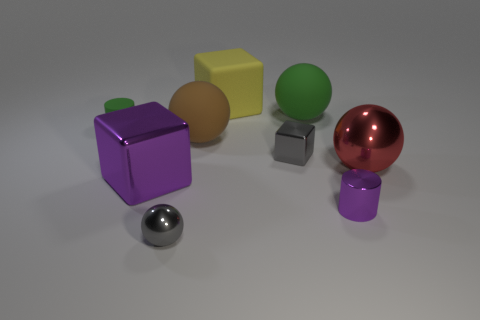What number of other things are there of the same material as the big yellow cube
Your answer should be compact. 3. Does the red ball have the same material as the tiny cylinder behind the red sphere?
Make the answer very short. No. Is the number of gray metallic objects that are to the right of the small purple object less than the number of purple shiny objects that are on the right side of the brown matte object?
Offer a very short reply. Yes. There is a cylinder that is right of the small gray cube; what color is it?
Make the answer very short. Purple. How many other things are there of the same color as the large metallic sphere?
Ensure brevity in your answer.  0. There is a gray shiny thing to the right of the yellow matte cube; is its size the same as the purple cylinder?
Provide a succinct answer. Yes. How many tiny metallic things are behind the gray block?
Make the answer very short. 0. Are there any green rubber blocks that have the same size as the red object?
Give a very brief answer. No. Do the large metal block and the shiny cylinder have the same color?
Give a very brief answer. Yes. The cylinder that is right of the small cylinder to the left of the large purple metallic block is what color?
Your answer should be compact. Purple. 